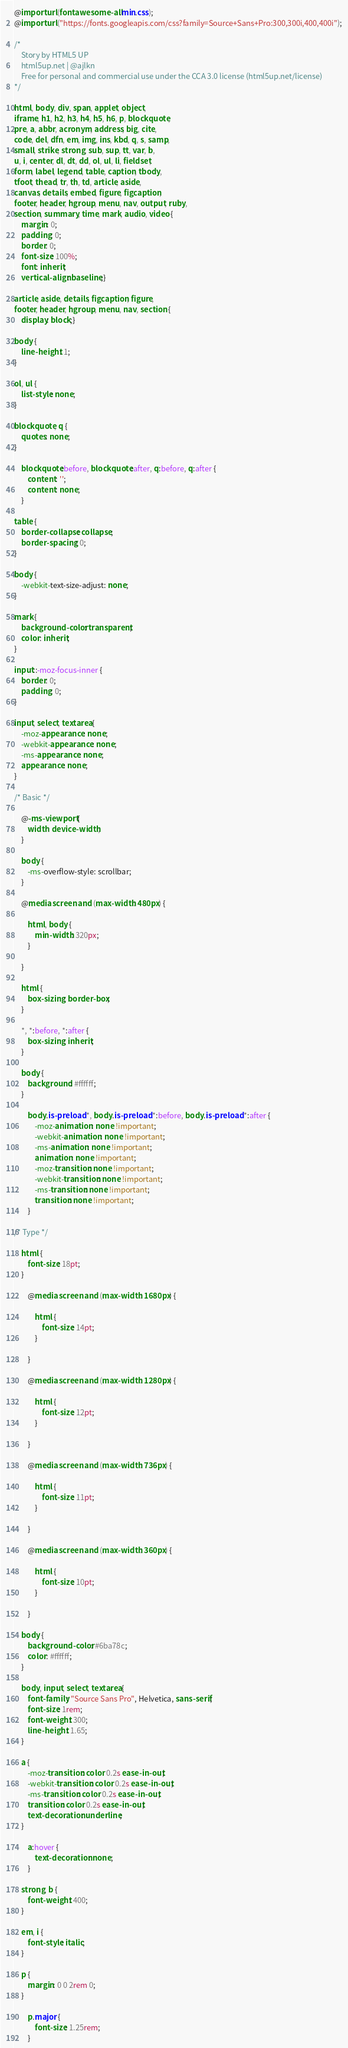Convert code to text. <code><loc_0><loc_0><loc_500><loc_500><_CSS_>@import url(fontawesome-all.min.css);
@import url("https://fonts.googleapis.com/css?family=Source+Sans+Pro:300,300i,400,400i");

/*
	Story by HTML5 UP
	html5up.net | @ajlkn
	Free for personal and commercial use under the CCA 3.0 license (html5up.net/license)
*/

html, body, div, span, applet, object,
iframe, h1, h2, h3, h4, h5, h6, p, blockquote,
pre, a, abbr, acronym, address, big, cite,
code, del, dfn, em, img, ins, kbd, q, s, samp,
small, strike, strong, sub, sup, tt, var, b,
u, i, center, dl, dt, dd, ol, ul, li, fieldset,
form, label, legend, table, caption, tbody,
tfoot, thead, tr, th, td, article, aside,
canvas, details, embed, figure, figcaption,
footer, header, hgroup, menu, nav, output, ruby,
section, summary, time, mark, audio, video {
	margin: 0;
	padding: 0;
	border: 0;
	font-size: 100%;
	font: inherit;
	vertical-align: baseline;}

article, aside, details, figcaption, figure,
footer, header, hgroup, menu, nav, section {
	display: block;}

body {
	line-height: 1;
}

ol, ul {
	list-style: none;
}

blockquote, q {
	quotes: none;
}

	blockquote:before, blockquote:after, q:before, q:after {
		content: '';
		content: none;
	}

table {
	border-collapse: collapse;
	border-spacing: 0;
}

body {
	-webkit-text-size-adjust: none;
}

mark {
	background-color: transparent;
	color: inherit;
}

input::-moz-focus-inner {
	border: 0;
	padding: 0;
}

input, select, textarea {
	-moz-appearance: none;
	-webkit-appearance: none;
	-ms-appearance: none;
	appearance: none;
}

/* Basic */

	@-ms-viewport {
		width: device-width;
	}

	body {
		-ms-overflow-style: scrollbar;
	}

	@media screen and (max-width: 480px) {

		html, body {
			min-width: 320px;
		}

	}

	html {
		box-sizing: border-box;
	}

	*, *:before, *:after {
		box-sizing: inherit;
	}

	body {
		background: #ffffff;
	}

		body.is-preload *, body.is-preload *:before, body.is-preload *:after {
			-moz-animation: none !important;
			-webkit-animation: none !important;
			-ms-animation: none !important;
			animation: none !important;
			-moz-transition: none !important;
			-webkit-transition: none !important;
			-ms-transition: none !important;
			transition: none !important;
		}

/* Type */

	html {
		font-size: 18pt;
	}

		@media screen and (max-width: 1680px) {

			html {
				font-size: 14pt;
			}

		}

		@media screen and (max-width: 1280px) {

			html {
				font-size: 12pt;
			}

		}

		@media screen and (max-width: 736px) {

			html {
				font-size: 11pt;
			}

		}

		@media screen and (max-width: 360px) {

			html {
				font-size: 10pt;
			}

		}

	body {
		background-color: #6ba78c;
		color: #ffffff;
	}

	body, input, select, textarea {
		font-family: "Source Sans Pro", Helvetica, sans-serif;
		font-size: 1rem;
		font-weight: 300;
		line-height: 1.65;
	}

	a {
		-moz-transition: color 0.2s ease-in-out;
		-webkit-transition: color 0.2s ease-in-out;
		-ms-transition: color 0.2s ease-in-out;
		transition: color 0.2s ease-in-out;
		text-decoration: underline;
	}

		a:hover {
			text-decoration: none;
		}

	strong, b {
		font-weight: 400;
	}

	em, i {
		font-style: italic;
	}

	p {
		margin: 0 0 2rem 0;
	}

		p.major {
			font-size: 1.25rem;
		}
</code> 